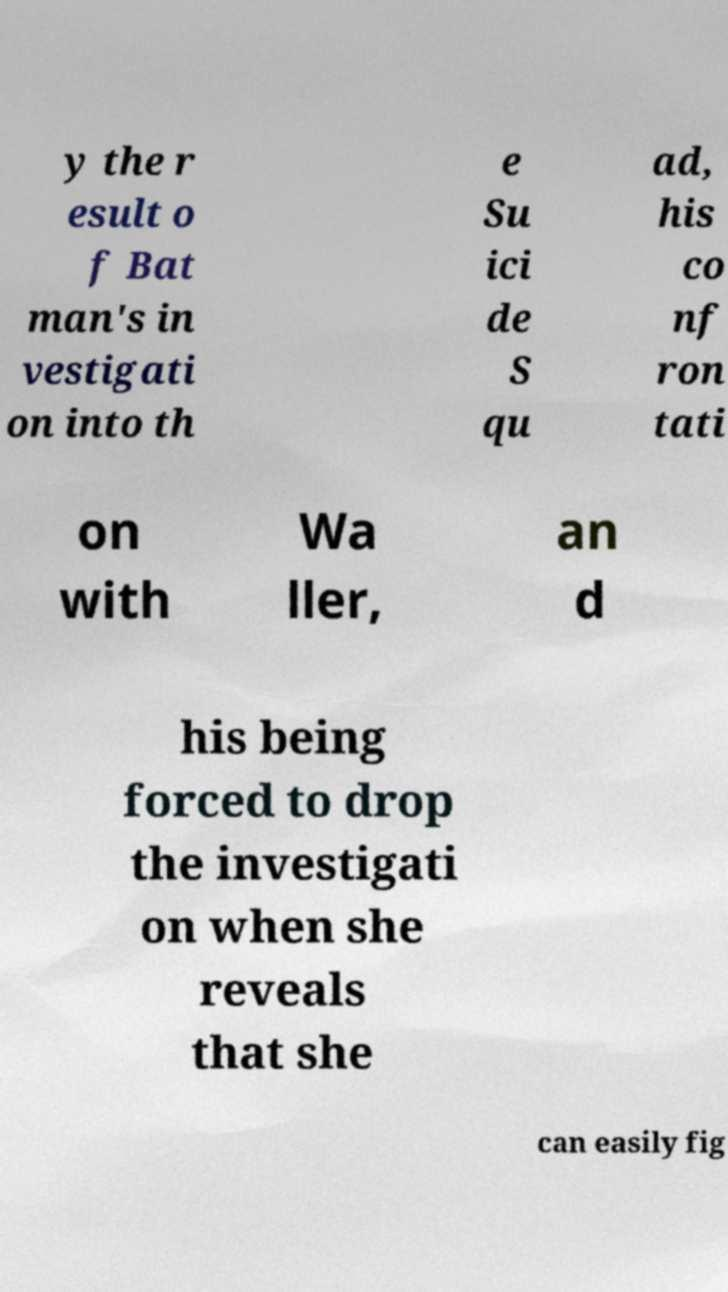There's text embedded in this image that I need extracted. Can you transcribe it verbatim? y the r esult o f Bat man's in vestigati on into th e Su ici de S qu ad, his co nf ron tati on with Wa ller, an d his being forced to drop the investigati on when she reveals that she can easily fig 